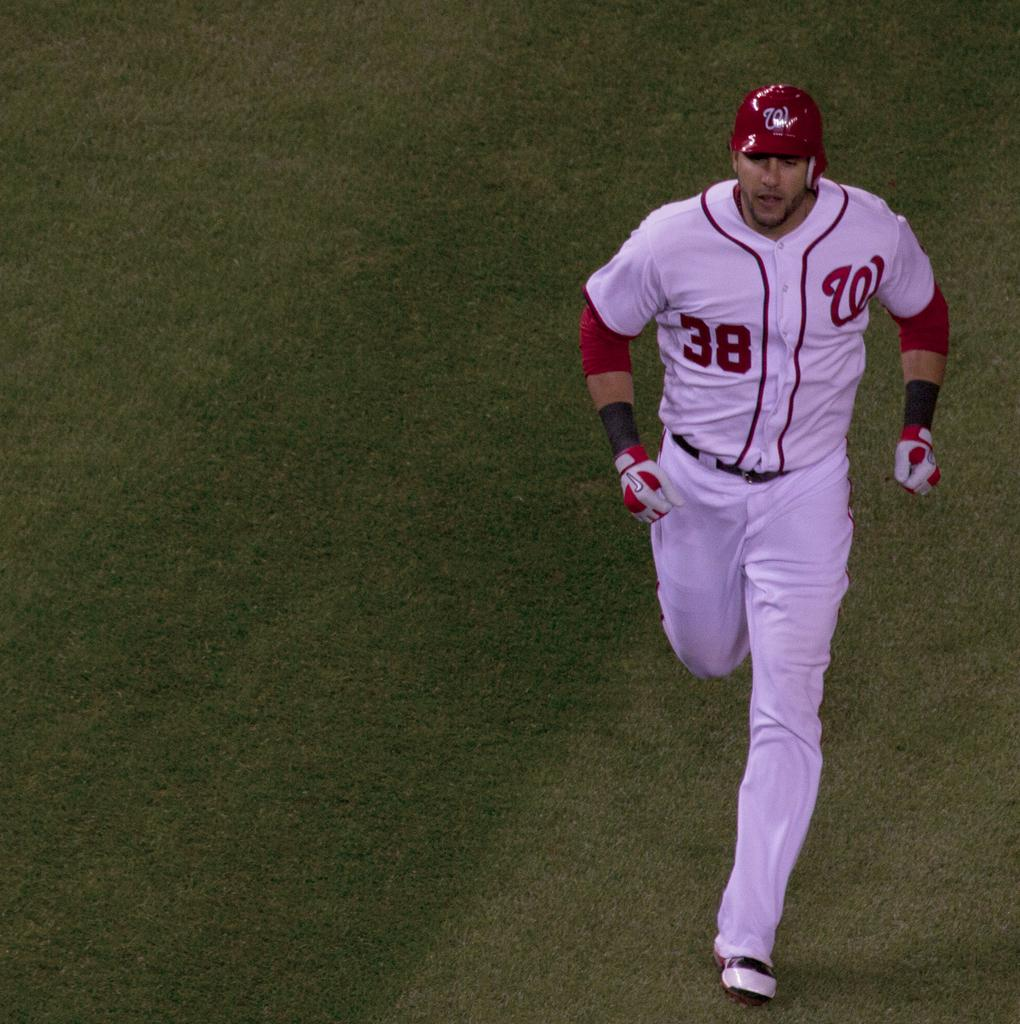<image>
Create a compact narrative representing the image presented. Player number 38 running off the field at the end of an inning. 